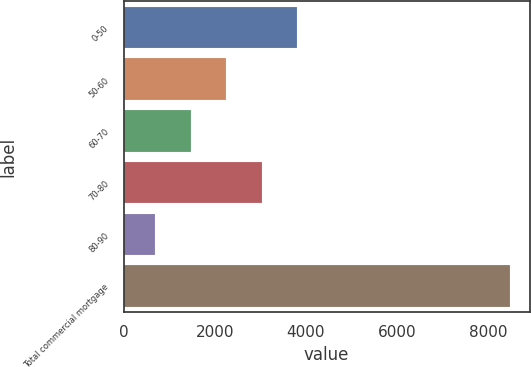Convert chart to OTSL. <chart><loc_0><loc_0><loc_500><loc_500><bar_chart><fcel>0-50<fcel>50-60<fcel>60-70<fcel>70-80<fcel>80-90<fcel>Total commercial mortgage<nl><fcel>3807.8<fcel>2248.4<fcel>1468.7<fcel>3028.1<fcel>689<fcel>8486<nl></chart> 